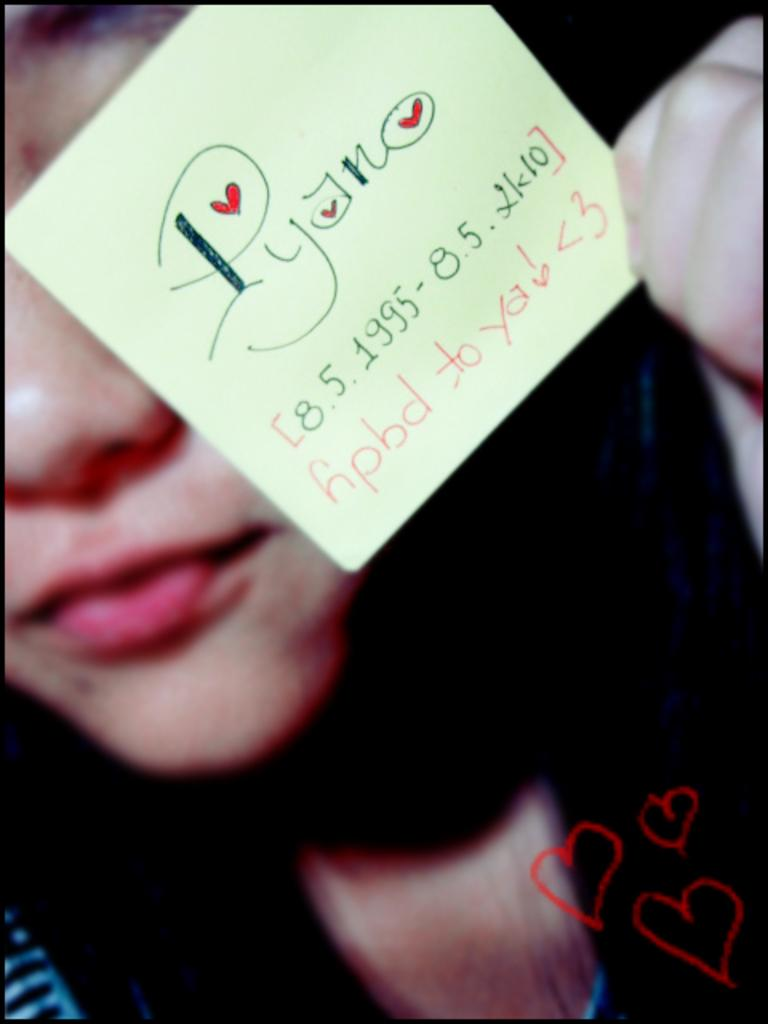Who is present in the image? There is a woman in the image. What is the woman holding in the image? The woman is holding a paper. What can be found on the paper that the woman is holding? The paper contains text and numbers. How was the image created? The image is an edited picture. What type of flowers can be seen in the image? There are no flowers present in the image. How does the woman's temper affect the decision she made in the image? The image does not provide any information about the woman's temper or the decision she made, as it only shows her holding a paper with text and numbers. 